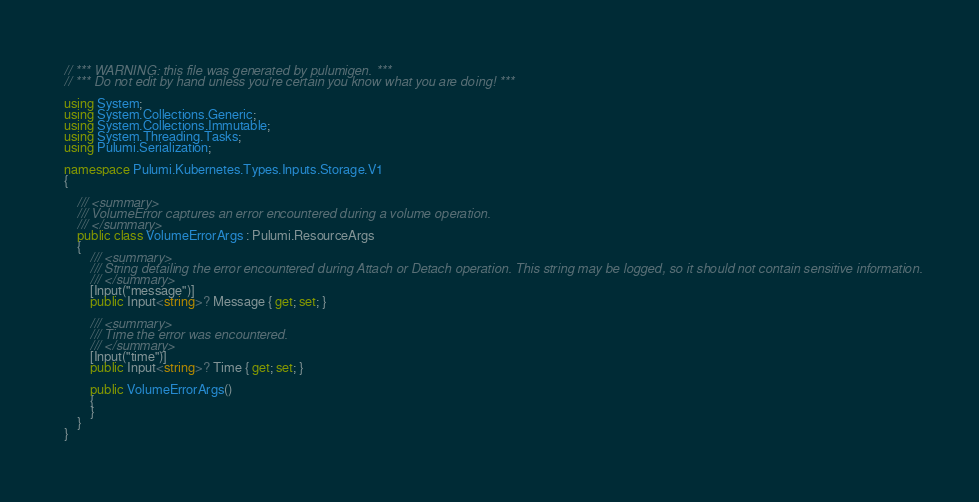Convert code to text. <code><loc_0><loc_0><loc_500><loc_500><_C#_>// *** WARNING: this file was generated by pulumigen. ***
// *** Do not edit by hand unless you're certain you know what you are doing! ***

using System;
using System.Collections.Generic;
using System.Collections.Immutable;
using System.Threading.Tasks;
using Pulumi.Serialization;

namespace Pulumi.Kubernetes.Types.Inputs.Storage.V1
{

    /// <summary>
    /// VolumeError captures an error encountered during a volume operation.
    /// </summary>
    public class VolumeErrorArgs : Pulumi.ResourceArgs
    {
        /// <summary>
        /// String detailing the error encountered during Attach or Detach operation. This string may be logged, so it should not contain sensitive information.
        /// </summary>
        [Input("message")]
        public Input<string>? Message { get; set; }

        /// <summary>
        /// Time the error was encountered.
        /// </summary>
        [Input("time")]
        public Input<string>? Time { get; set; }

        public VolumeErrorArgs()
        {
        }
    }
}
</code> 